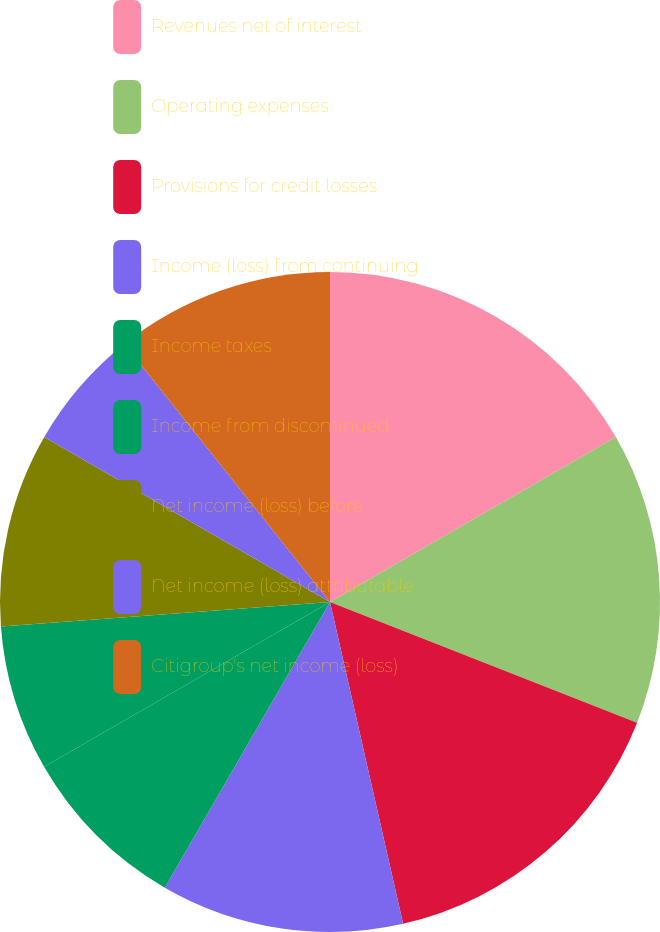Convert chart to OTSL. <chart><loc_0><loc_0><loc_500><loc_500><pie_chart><fcel>Revenues net of interest<fcel>Operating expenses<fcel>Provisions for credit losses<fcel>Income (loss) from continuing<fcel>Income taxes<fcel>Income from discontinued<fcel>Net income (loss) before<fcel>Net income (loss) attributable<fcel>Citigroup's net income (loss)<nl><fcel>16.67%<fcel>14.29%<fcel>15.48%<fcel>11.9%<fcel>8.33%<fcel>7.14%<fcel>9.52%<fcel>5.95%<fcel>10.71%<nl></chart> 